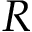Convert formula to latex. <formula><loc_0><loc_0><loc_500><loc_500>R</formula> 